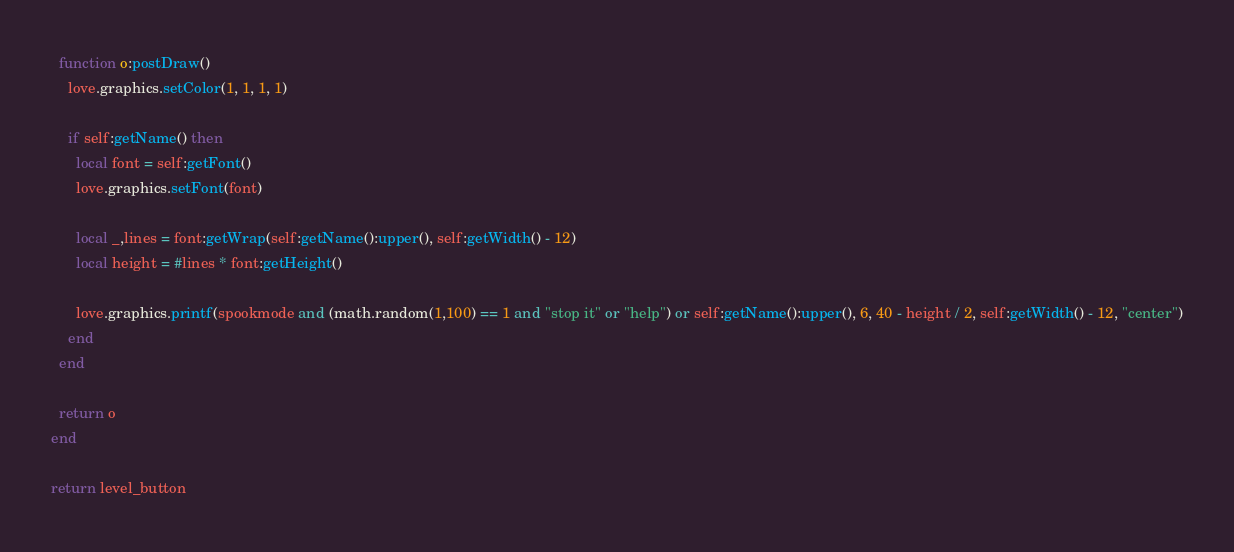<code> <loc_0><loc_0><loc_500><loc_500><_Lua_>  function o:postDraw()
    love.graphics.setColor(1, 1, 1, 1)

    if self:getName() then
      local font = self:getFont()
      love.graphics.setFont(font)

      local _,lines = font:getWrap(self:getName():upper(), self:getWidth() - 12)
      local height = #lines * font:getHeight()

      love.graphics.printf(spookmode and (math.random(1,100) == 1 and "stop it" or "help") or self:getName():upper(), 6, 40 - height / 2, self:getWidth() - 12, "center")
    end
  end

  return o
end

return level_button</code> 